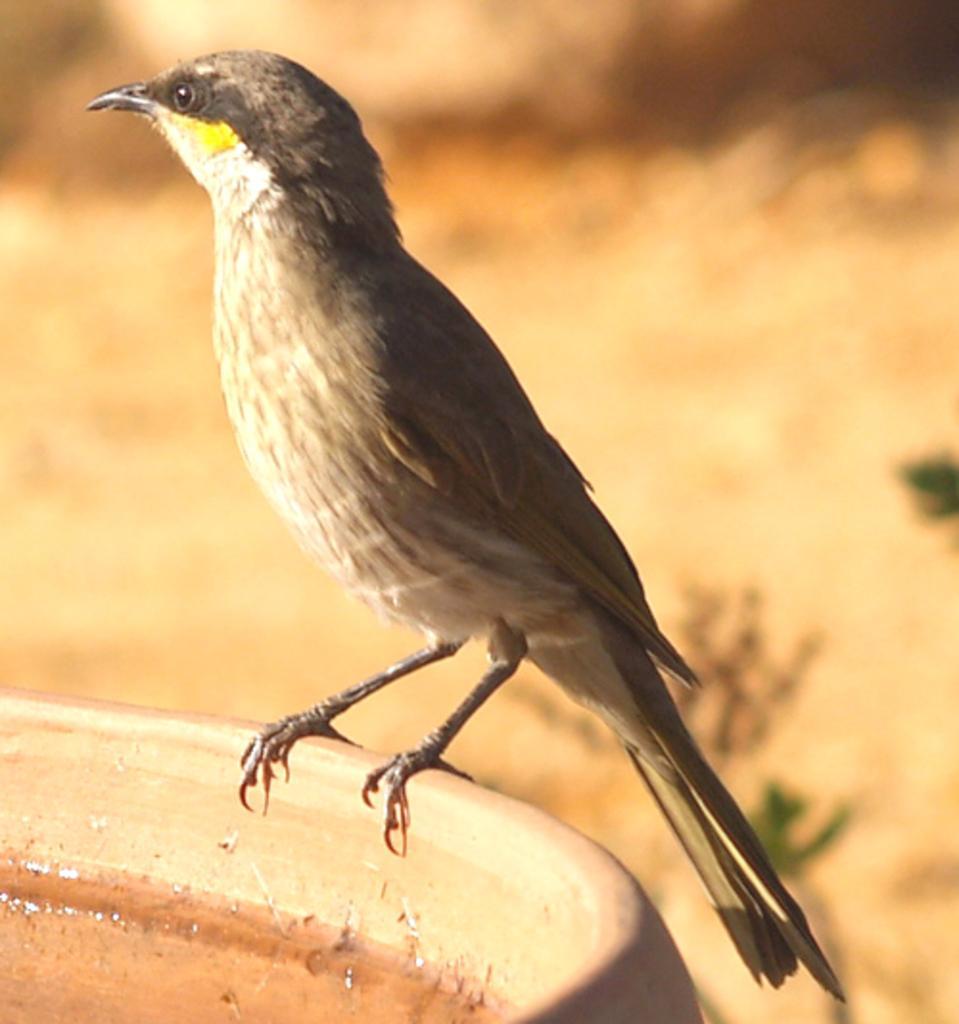Please provide a concise description of this image. In this image, we can see a bird sitting and we can see water, there is a blur background. 